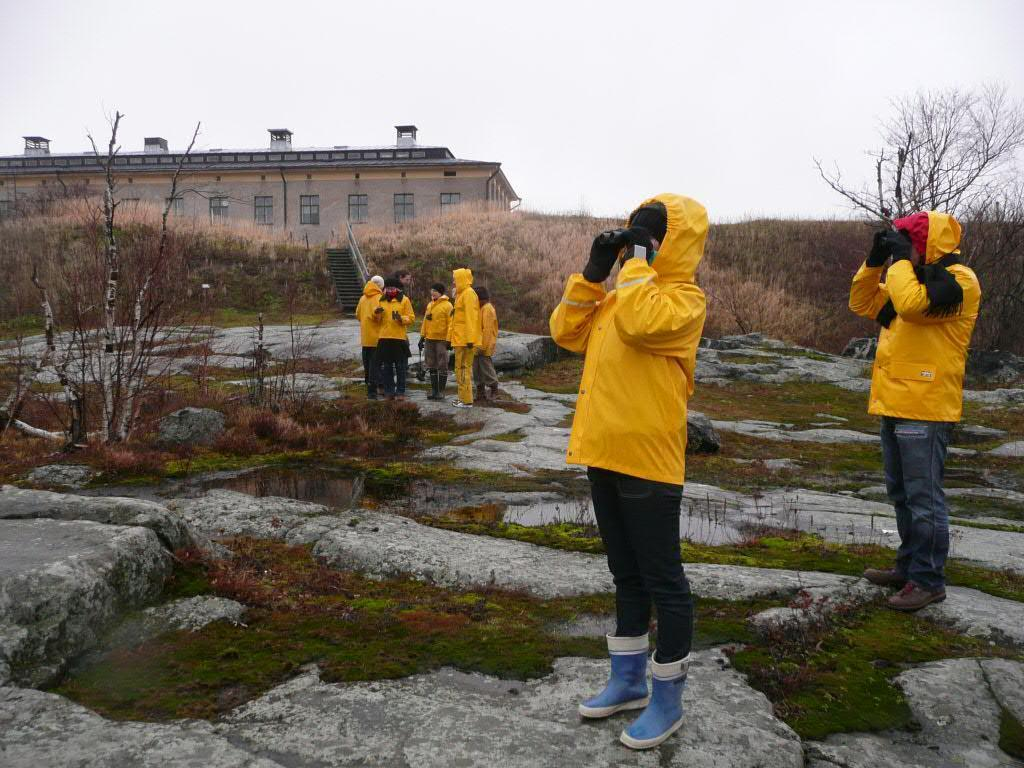Who or what is present in the image? There are people in the image. What are the people wearing? The people are wearing yellow jackets. What else can be seen in the image besides the people? There are plants in the image. What is located at the left back of the image? There is a building at the left back of the image. Reasoning: Let' Let's think step by step in order to produce the conversation. We start by identifying the main subjects in the image, which are the people. Then, we describe their clothing, which is yellow jackets. Next, we mention the presence of plants as additional elements in the image. Finally, we identify the building located at the left back of the image. Each question is designed to elicit a specific detail about the image that is known from the provided facts. Absurd Question/Answer: How many gold cows are present in the image? There are no gold cows present in the image; the facts provided do not mention any cows or gold objects. 